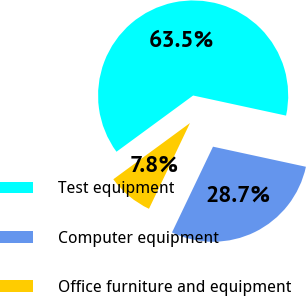<chart> <loc_0><loc_0><loc_500><loc_500><pie_chart><fcel>Test equipment<fcel>Computer equipment<fcel>Office furniture and equipment<nl><fcel>63.47%<fcel>28.71%<fcel>7.83%<nl></chart> 